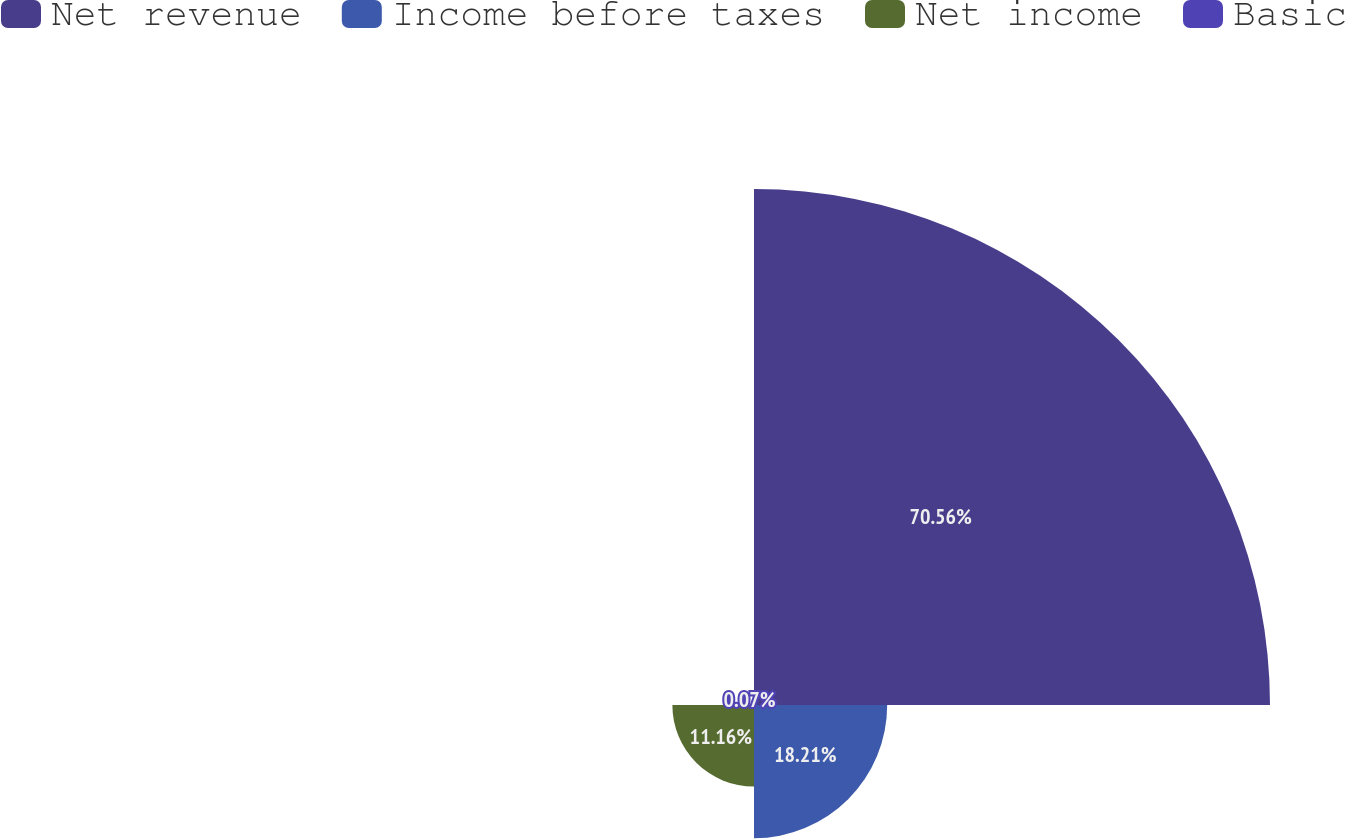Convert chart to OTSL. <chart><loc_0><loc_0><loc_500><loc_500><pie_chart><fcel>Net revenue<fcel>Income before taxes<fcel>Net income<fcel>Basic<nl><fcel>70.55%<fcel>18.21%<fcel>11.16%<fcel>0.07%<nl></chart> 